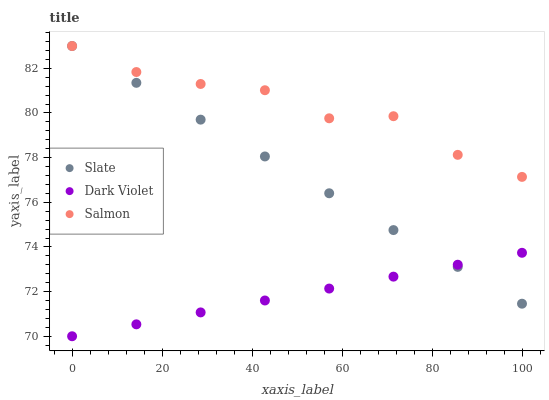Does Dark Violet have the minimum area under the curve?
Answer yes or no. Yes. Does Salmon have the maximum area under the curve?
Answer yes or no. Yes. Does Salmon have the minimum area under the curve?
Answer yes or no. No. Does Dark Violet have the maximum area under the curve?
Answer yes or no. No. Is Dark Violet the smoothest?
Answer yes or no. Yes. Is Salmon the roughest?
Answer yes or no. Yes. Is Salmon the smoothest?
Answer yes or no. No. Is Dark Violet the roughest?
Answer yes or no. No. Does Dark Violet have the lowest value?
Answer yes or no. Yes. Does Salmon have the lowest value?
Answer yes or no. No. Does Salmon have the highest value?
Answer yes or no. Yes. Does Dark Violet have the highest value?
Answer yes or no. No. Is Dark Violet less than Salmon?
Answer yes or no. Yes. Is Salmon greater than Dark Violet?
Answer yes or no. Yes. Does Slate intersect Salmon?
Answer yes or no. Yes. Is Slate less than Salmon?
Answer yes or no. No. Is Slate greater than Salmon?
Answer yes or no. No. Does Dark Violet intersect Salmon?
Answer yes or no. No. 